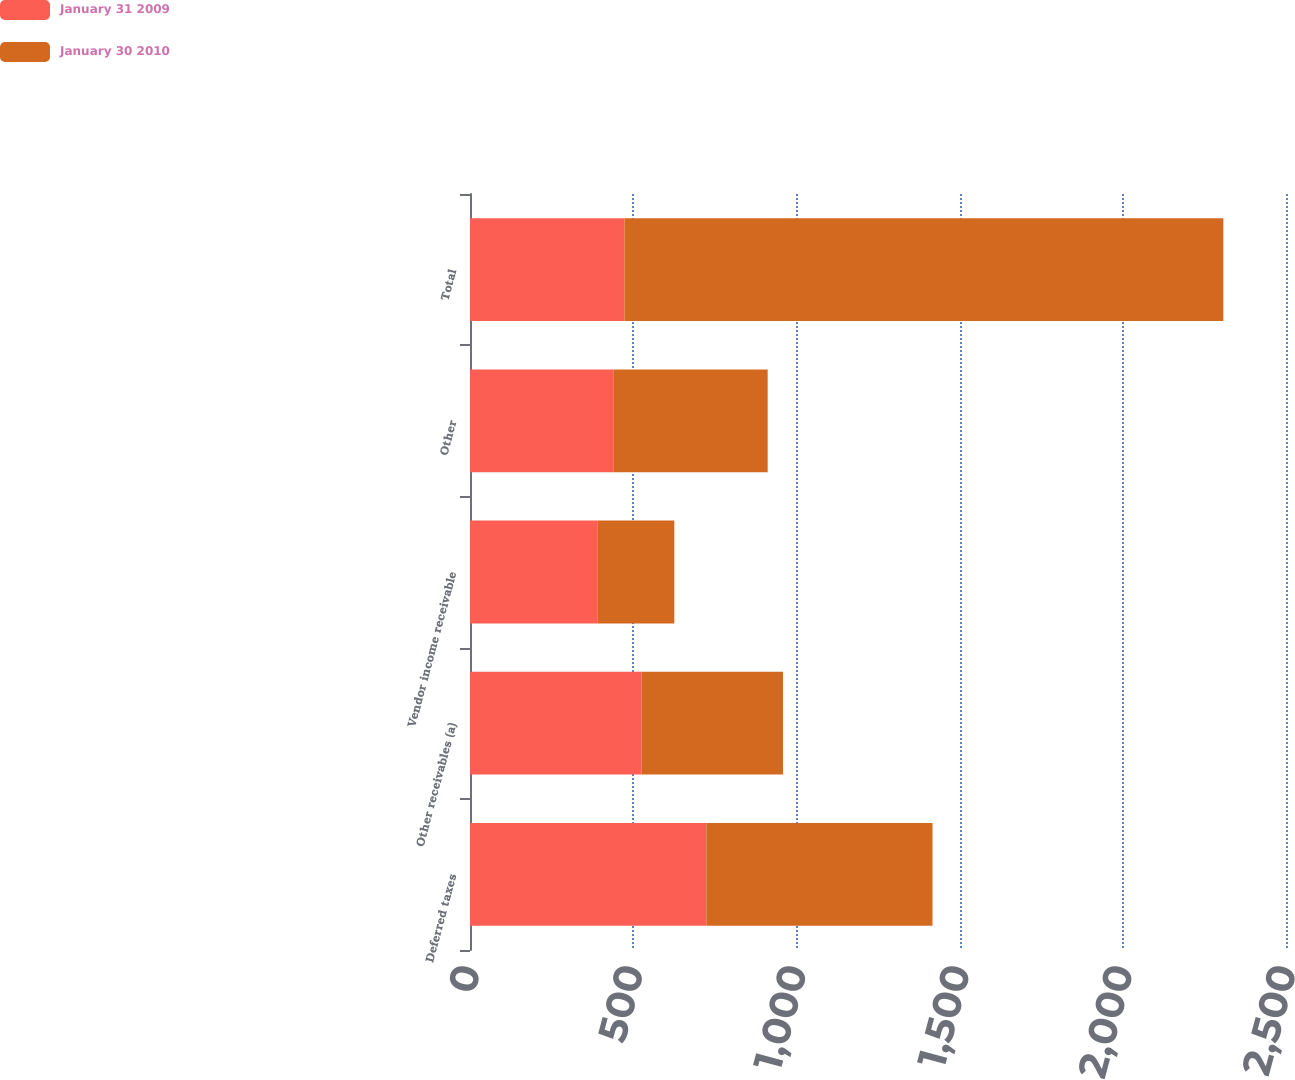Convert chart to OTSL. <chart><loc_0><loc_0><loc_500><loc_500><stacked_bar_chart><ecel><fcel>Deferred taxes<fcel>Other receivables (a)<fcel>Vendor income receivable<fcel>Other<fcel>Total<nl><fcel>January 31 2009<fcel>724<fcel>526<fcel>390<fcel>439<fcel>473<nl><fcel>January 30 2010<fcel>693<fcel>433<fcel>236<fcel>473<fcel>1835<nl></chart> 